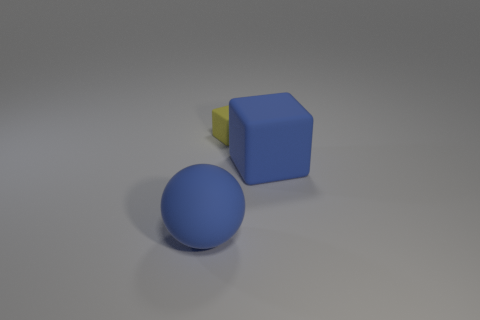Add 3 blue blocks. How many objects exist? 6 Subtract all balls. How many objects are left? 2 Subtract 0 purple spheres. How many objects are left? 3 Subtract all small yellow cubes. Subtract all big rubber spheres. How many objects are left? 1 Add 1 large blue objects. How many large blue objects are left? 3 Add 1 yellow rubber blocks. How many yellow rubber blocks exist? 2 